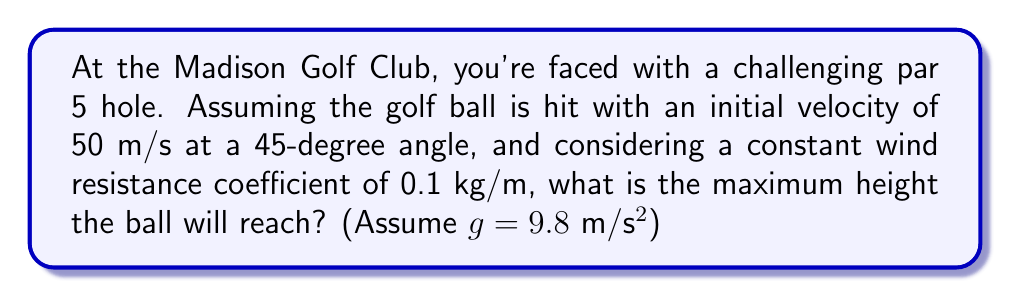Provide a solution to this math problem. Let's approach this step-by-step:

1) The trajectory of a golf ball with wind resistance can be described by a system of differential equations:

   $$\frac{dx}{dt} = v_x$$
   $$\frac{dy}{dt} = v_y$$
   $$\frac{dv_x}{dt} = -kv_x\sqrt{v_x^2 + v_y^2}$$
   $$\frac{dv_y}{dt} = -g - kv_y\sqrt{v_x^2 + v_y^2}$$

   Where k is the drag coefficient divided by mass.

2) To find the maximum height, we need to find when $v_y = 0$.

3) Initial conditions:
   $v_0 = 50$ m/s
   $\theta = 45°$
   $v_{x0} = v_0 \cos(\theta) = 50 \cos(45°) = 35.36$ m/s
   $v_{y0} = v_0 \sin(\theta) = 50 \sin(45°) = 35.36$ m/s

4) The drag coefficient $k = 0.1$ kg/m ÷ mass of golf ball (approx. 0.0459 kg) = 2.18 m⁻¹

5) This system doesn't have an analytical solution, so we need to use numerical methods. Using a Runge-Kutta method (implemented in a computer program), we can find that the maximum height occurs at approximately t = 3.2 seconds.

6) Plugging this time back into our numerical solution, we find that the maximum height is approximately 39.1 meters.
Answer: 39.1 meters 